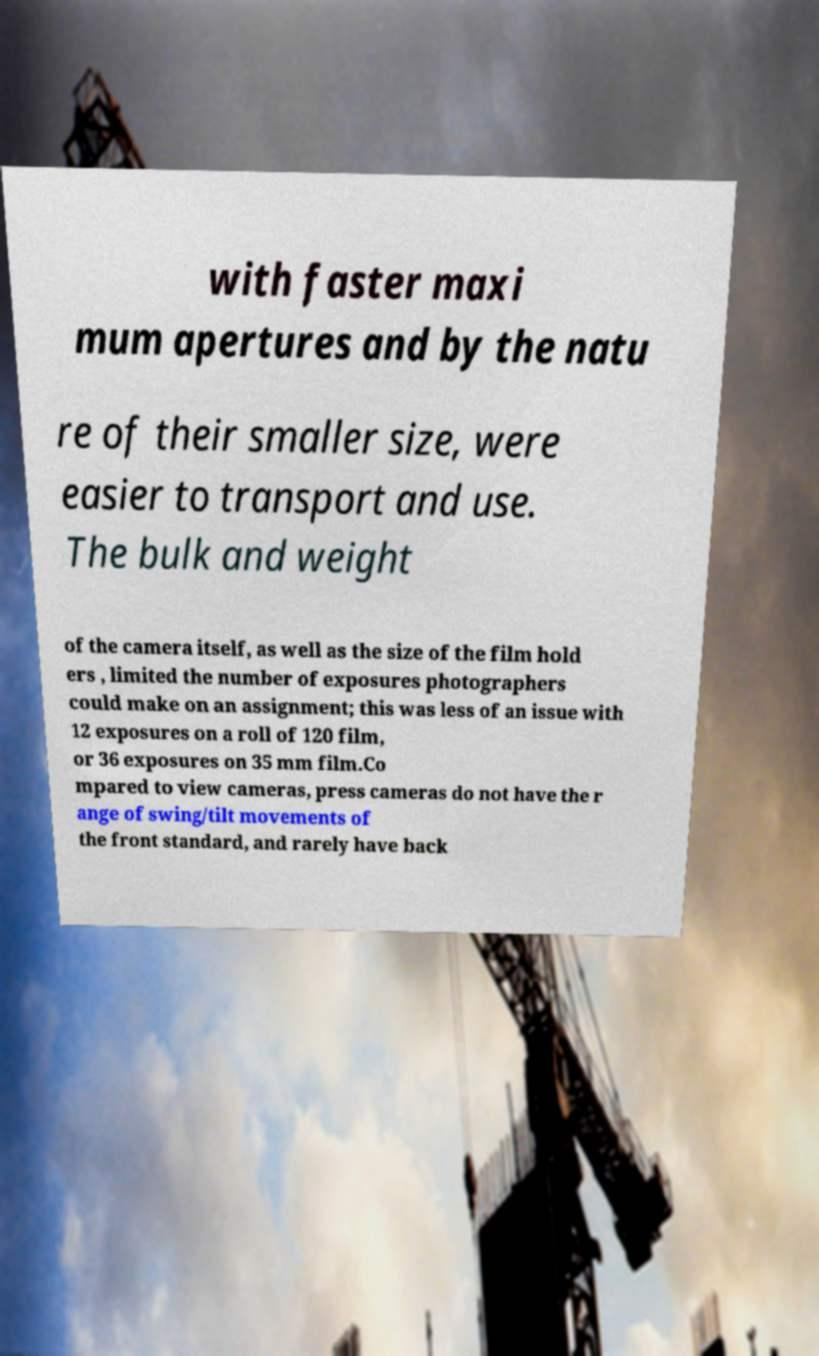Could you extract and type out the text from this image? with faster maxi mum apertures and by the natu re of their smaller size, were easier to transport and use. The bulk and weight of the camera itself, as well as the size of the film hold ers , limited the number of exposures photographers could make on an assignment; this was less of an issue with 12 exposures on a roll of 120 film, or 36 exposures on 35 mm film.Co mpared to view cameras, press cameras do not have the r ange of swing/tilt movements of the front standard, and rarely have back 